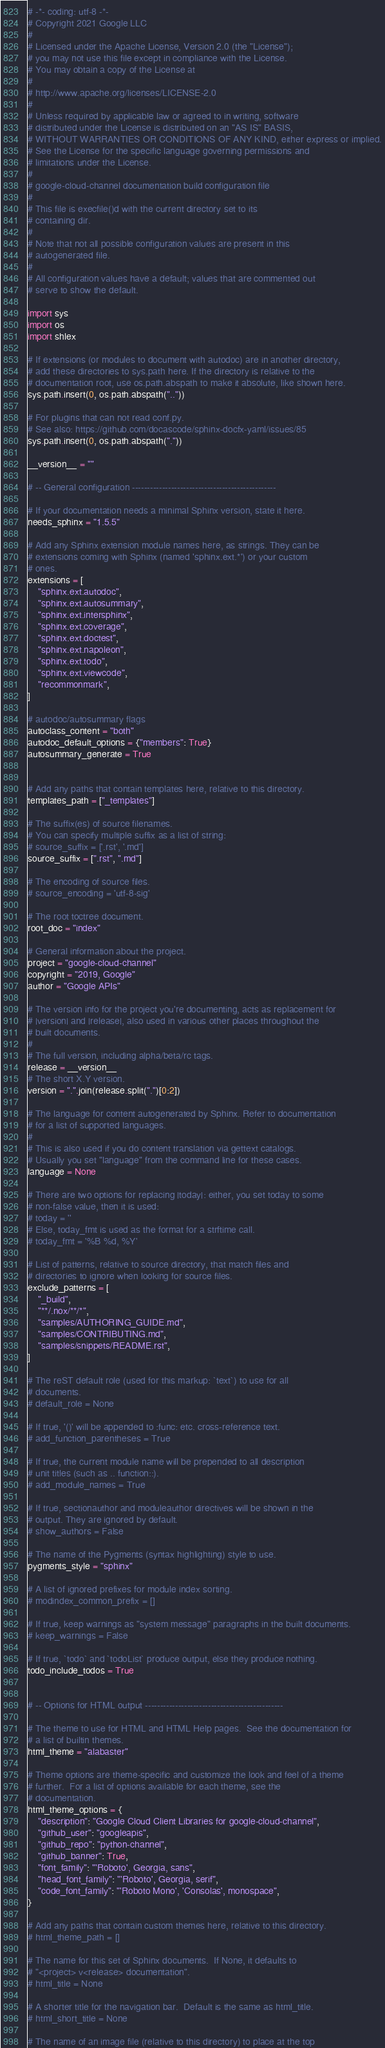<code> <loc_0><loc_0><loc_500><loc_500><_Python_># -*- coding: utf-8 -*-
# Copyright 2021 Google LLC
#
# Licensed under the Apache License, Version 2.0 (the "License");
# you may not use this file except in compliance with the License.
# You may obtain a copy of the License at
#
# http://www.apache.org/licenses/LICENSE-2.0
#
# Unless required by applicable law or agreed to in writing, software
# distributed under the License is distributed on an "AS IS" BASIS,
# WITHOUT WARRANTIES OR CONDITIONS OF ANY KIND, either express or implied.
# See the License for the specific language governing permissions and
# limitations under the License.
#
# google-cloud-channel documentation build configuration file
#
# This file is execfile()d with the current directory set to its
# containing dir.
#
# Note that not all possible configuration values are present in this
# autogenerated file.
#
# All configuration values have a default; values that are commented out
# serve to show the default.

import sys
import os
import shlex

# If extensions (or modules to document with autodoc) are in another directory,
# add these directories to sys.path here. If the directory is relative to the
# documentation root, use os.path.abspath to make it absolute, like shown here.
sys.path.insert(0, os.path.abspath(".."))

# For plugins that can not read conf.py.
# See also: https://github.com/docascode/sphinx-docfx-yaml/issues/85
sys.path.insert(0, os.path.abspath("."))

__version__ = ""

# -- General configuration ------------------------------------------------

# If your documentation needs a minimal Sphinx version, state it here.
needs_sphinx = "1.5.5"

# Add any Sphinx extension module names here, as strings. They can be
# extensions coming with Sphinx (named 'sphinx.ext.*') or your custom
# ones.
extensions = [
    "sphinx.ext.autodoc",
    "sphinx.ext.autosummary",
    "sphinx.ext.intersphinx",
    "sphinx.ext.coverage",
    "sphinx.ext.doctest",
    "sphinx.ext.napoleon",
    "sphinx.ext.todo",
    "sphinx.ext.viewcode",
    "recommonmark",
]

# autodoc/autosummary flags
autoclass_content = "both"
autodoc_default_options = {"members": True}
autosummary_generate = True


# Add any paths that contain templates here, relative to this directory.
templates_path = ["_templates"]

# The suffix(es) of source filenames.
# You can specify multiple suffix as a list of string:
# source_suffix = ['.rst', '.md']
source_suffix = [".rst", ".md"]

# The encoding of source files.
# source_encoding = 'utf-8-sig'

# The root toctree document.
root_doc = "index"

# General information about the project.
project = "google-cloud-channel"
copyright = "2019, Google"
author = "Google APIs"

# The version info for the project you're documenting, acts as replacement for
# |version| and |release|, also used in various other places throughout the
# built documents.
#
# The full version, including alpha/beta/rc tags.
release = __version__
# The short X.Y version.
version = ".".join(release.split(".")[0:2])

# The language for content autogenerated by Sphinx. Refer to documentation
# for a list of supported languages.
#
# This is also used if you do content translation via gettext catalogs.
# Usually you set "language" from the command line for these cases.
language = None

# There are two options for replacing |today|: either, you set today to some
# non-false value, then it is used:
# today = ''
# Else, today_fmt is used as the format for a strftime call.
# today_fmt = '%B %d, %Y'

# List of patterns, relative to source directory, that match files and
# directories to ignore when looking for source files.
exclude_patterns = [
    "_build",
    "**/.nox/**/*",
    "samples/AUTHORING_GUIDE.md",
    "samples/CONTRIBUTING.md",
    "samples/snippets/README.rst",
]

# The reST default role (used for this markup: `text`) to use for all
# documents.
# default_role = None

# If true, '()' will be appended to :func: etc. cross-reference text.
# add_function_parentheses = True

# If true, the current module name will be prepended to all description
# unit titles (such as .. function::).
# add_module_names = True

# If true, sectionauthor and moduleauthor directives will be shown in the
# output. They are ignored by default.
# show_authors = False

# The name of the Pygments (syntax highlighting) style to use.
pygments_style = "sphinx"

# A list of ignored prefixes for module index sorting.
# modindex_common_prefix = []

# If true, keep warnings as "system message" paragraphs in the built documents.
# keep_warnings = False

# If true, `todo` and `todoList` produce output, else they produce nothing.
todo_include_todos = True


# -- Options for HTML output ----------------------------------------------

# The theme to use for HTML and HTML Help pages.  See the documentation for
# a list of builtin themes.
html_theme = "alabaster"

# Theme options are theme-specific and customize the look and feel of a theme
# further.  For a list of options available for each theme, see the
# documentation.
html_theme_options = {
    "description": "Google Cloud Client Libraries for google-cloud-channel",
    "github_user": "googleapis",
    "github_repo": "python-channel",
    "github_banner": True,
    "font_family": "'Roboto', Georgia, sans",
    "head_font_family": "'Roboto', Georgia, serif",
    "code_font_family": "'Roboto Mono', 'Consolas', monospace",
}

# Add any paths that contain custom themes here, relative to this directory.
# html_theme_path = []

# The name for this set of Sphinx documents.  If None, it defaults to
# "<project> v<release> documentation".
# html_title = None

# A shorter title for the navigation bar.  Default is the same as html_title.
# html_short_title = None

# The name of an image file (relative to this directory) to place at the top</code> 